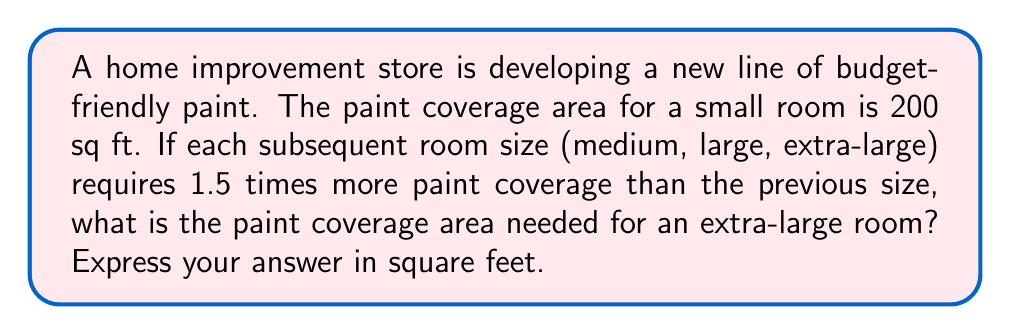What is the answer to this math problem? Let's approach this step-by-step:

1) We're dealing with a geometric progression where each term is 1.5 times the previous term.

2) The first term (small room) is 200 sq ft.

3) Let's calculate each room size:

   Small room: $a_1 = 200$ sq ft
   Medium room: $a_2 = 200 * 1.5 = 300$ sq ft
   Large room: $a_3 = 300 * 1.5 = 450$ sq ft
   Extra-large room: $a_4 = 450 * 1.5 = 675$ sq ft

4) We can also express this using the geometric sequence formula:

   $a_n = a_1 * r^{n-1}$

   Where $a_1 = 200$, $r = 1.5$, and we want $a_4$

5) Plugging in the values:

   $a_4 = 200 * (1.5)^{4-1} = 200 * (1.5)^3 = 200 * 3.375 = 675$

Therefore, the paint coverage area needed for an extra-large room is 675 sq ft.
Answer: 675 sq ft 